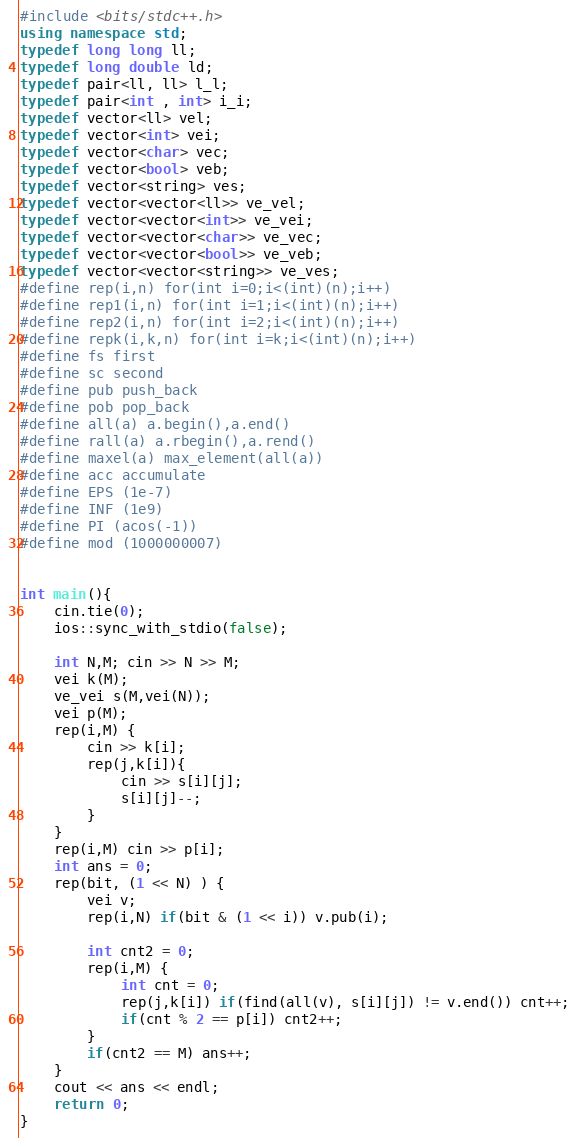Convert code to text. <code><loc_0><loc_0><loc_500><loc_500><_C++_>#include <bits/stdc++.h>
using namespace std;
typedef long long ll;
typedef long double ld;
typedef pair<ll, ll> l_l;
typedef pair<int , int> i_i;
typedef vector<ll> vel;
typedef vector<int> vei;
typedef vector<char> vec;
typedef vector<bool> veb;
typedef vector<string> ves;
typedef vector<vector<ll>> ve_vel;
typedef vector<vector<int>> ve_vei;
typedef vector<vector<char>> ve_vec;
typedef vector<vector<bool>> ve_veb;
typedef vector<vector<string>> ve_ves;
#define rep(i,n) for(int i=0;i<(int)(n);i++)
#define rep1(i,n) for(int i=1;i<(int)(n);i++)
#define rep2(i,n) for(int i=2;i<(int)(n);i++)
#define repk(i,k,n) for(int i=k;i<(int)(n);i++)
#define fs first
#define sc second
#define pub push_back
#define pob pop_back
#define all(a) a.begin(),a.end()
#define rall(a) a.rbegin(),a.rend()
#define maxel(a) max_element(all(a))
#define acc accumulate
#define EPS (1e-7)
#define INF (1e9)
#define PI (acos(-1))
#define mod (1000000007)


int main(){
	cin.tie(0);
	ios::sync_with_stdio(false);

    int N,M; cin >> N >> M;
    vei k(M);
    ve_vei s(M,vei(N));
    vei p(M);
    rep(i,M) {
        cin >> k[i];
        rep(j,k[i]){
            cin >> s[i][j];
            s[i][j]--;
        }
    }
    rep(i,M) cin >> p[i];
    int ans = 0;
    rep(bit, (1 << N) ) {
        vei v;
        rep(i,N) if(bit & (1 << i)) v.pub(i);

        int cnt2 = 0;
        rep(i,M) {
            int cnt = 0;
            rep(j,k[i]) if(find(all(v), s[i][j]) != v.end()) cnt++;
            if(cnt % 2 == p[i]) cnt2++;
        }
        if(cnt2 == M) ans++;
    }
    cout << ans << endl;
    return 0;
}</code> 